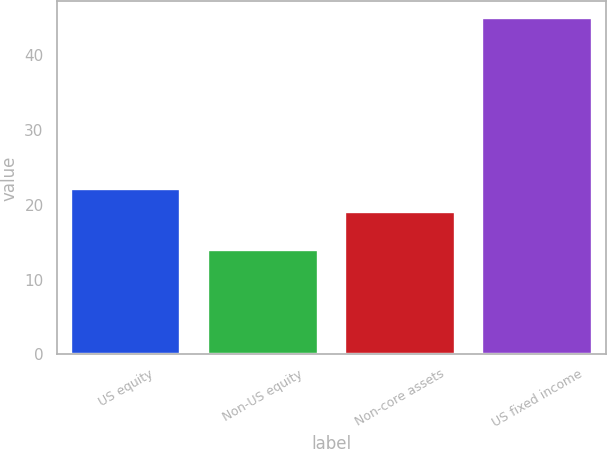Convert chart. <chart><loc_0><loc_0><loc_500><loc_500><bar_chart><fcel>US equity<fcel>Non-US equity<fcel>Non-core assets<fcel>US fixed income<nl><fcel>22.1<fcel>14<fcel>19<fcel>45<nl></chart> 